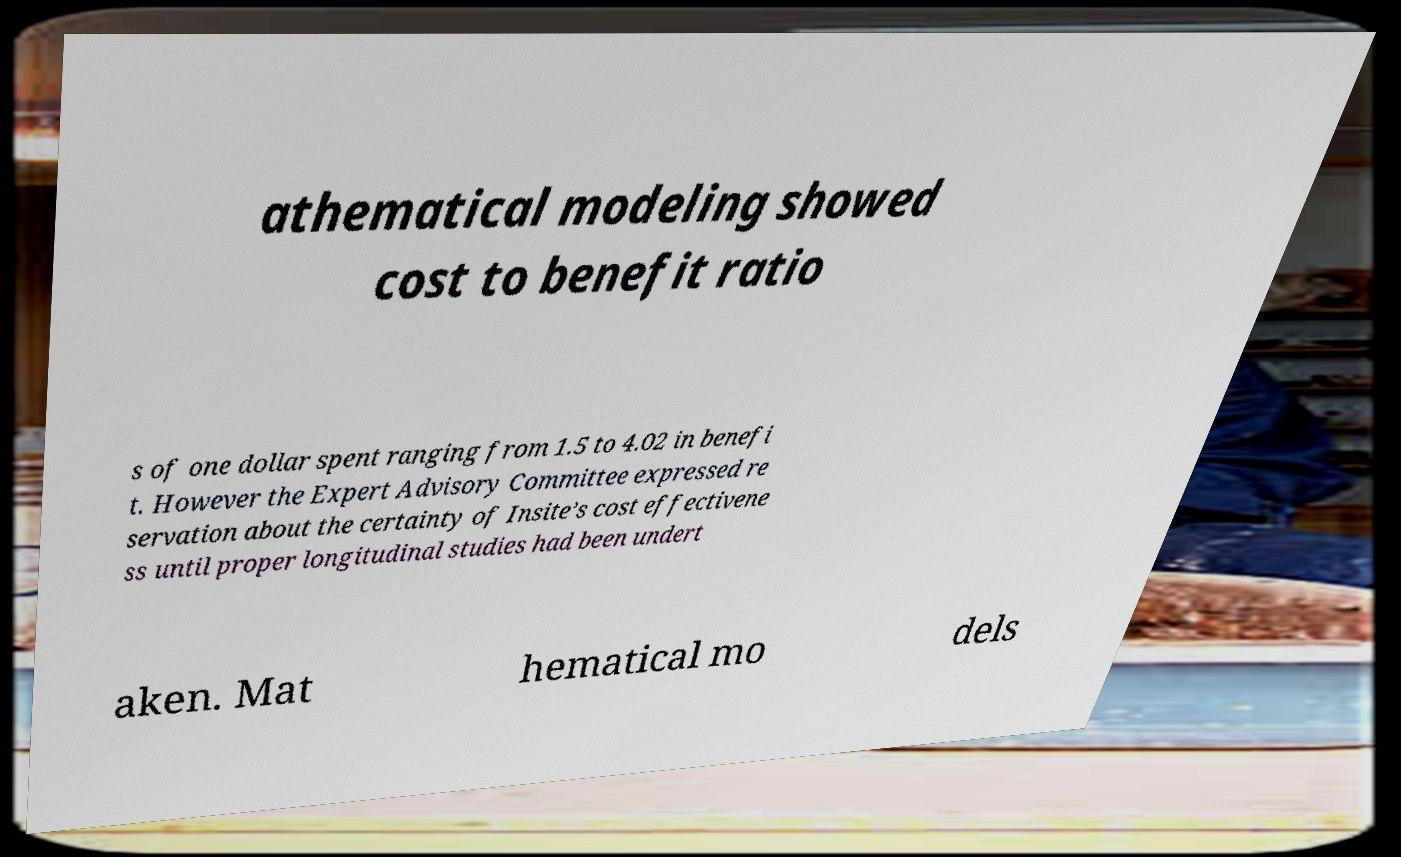Can you accurately transcribe the text from the provided image for me? athematical modeling showed cost to benefit ratio s of one dollar spent ranging from 1.5 to 4.02 in benefi t. However the Expert Advisory Committee expressed re servation about the certainty of Insite’s cost effectivene ss until proper longitudinal studies had been undert aken. Mat hematical mo dels 